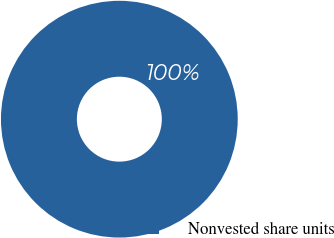<chart> <loc_0><loc_0><loc_500><loc_500><pie_chart><fcel>Nonvested share units<nl><fcel>100.0%<nl></chart> 